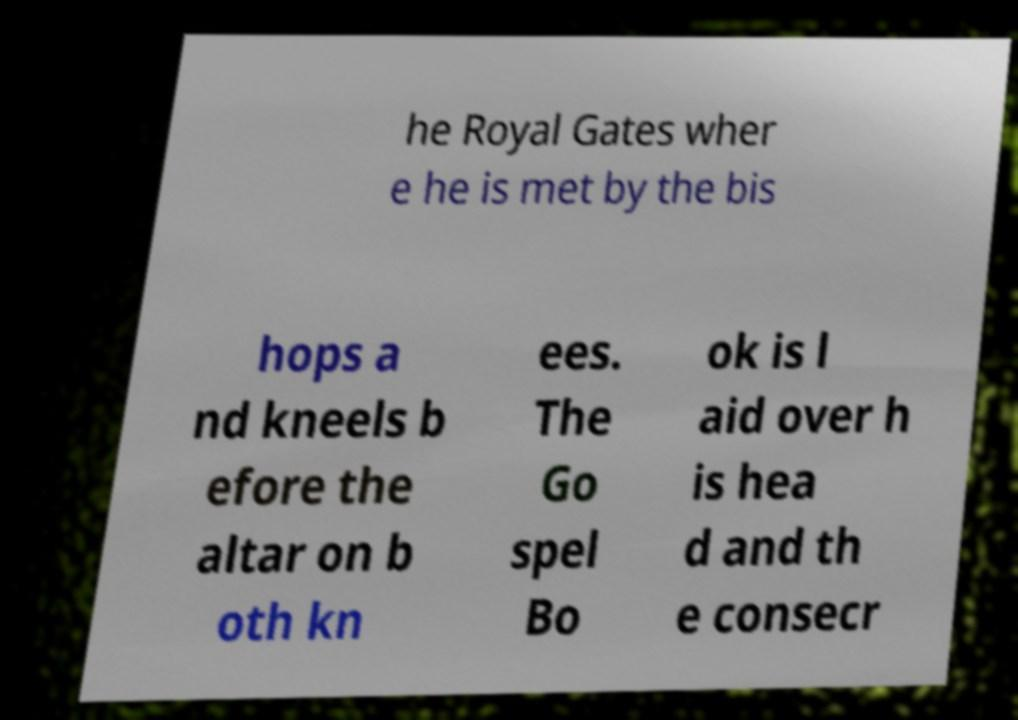Can you read and provide the text displayed in the image?This photo seems to have some interesting text. Can you extract and type it out for me? he Royal Gates wher e he is met by the bis hops a nd kneels b efore the altar on b oth kn ees. The Go spel Bo ok is l aid over h is hea d and th e consecr 